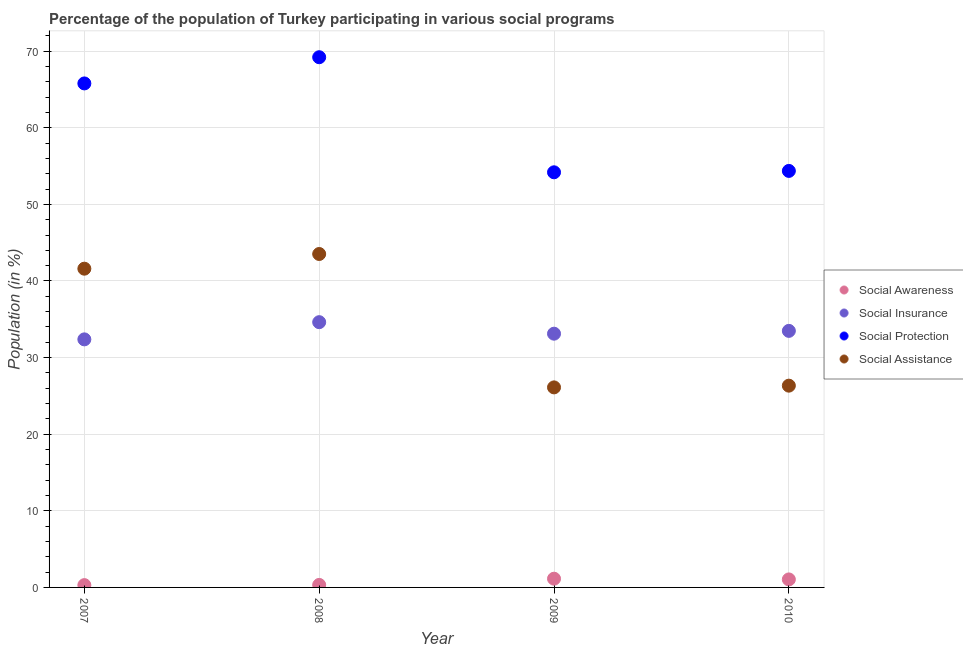How many different coloured dotlines are there?
Provide a short and direct response. 4. What is the participation of population in social protection programs in 2010?
Provide a succinct answer. 54.37. Across all years, what is the maximum participation of population in social awareness programs?
Your answer should be compact. 1.14. Across all years, what is the minimum participation of population in social protection programs?
Make the answer very short. 54.19. In which year was the participation of population in social insurance programs minimum?
Keep it short and to the point. 2007. What is the total participation of population in social awareness programs in the graph?
Keep it short and to the point. 2.81. What is the difference between the participation of population in social protection programs in 2007 and that in 2010?
Provide a succinct answer. 11.42. What is the difference between the participation of population in social insurance programs in 2010 and the participation of population in social awareness programs in 2009?
Ensure brevity in your answer.  32.35. What is the average participation of population in social assistance programs per year?
Provide a succinct answer. 34.39. In the year 2008, what is the difference between the participation of population in social protection programs and participation of population in social assistance programs?
Offer a very short reply. 25.68. In how many years, is the participation of population in social awareness programs greater than 60 %?
Your response must be concise. 0. What is the ratio of the participation of population in social assistance programs in 2007 to that in 2008?
Offer a very short reply. 0.96. Is the participation of population in social insurance programs in 2007 less than that in 2009?
Give a very brief answer. Yes. Is the difference between the participation of population in social insurance programs in 2007 and 2010 greater than the difference between the participation of population in social protection programs in 2007 and 2010?
Keep it short and to the point. No. What is the difference between the highest and the second highest participation of population in social insurance programs?
Make the answer very short. 1.14. What is the difference between the highest and the lowest participation of population in social awareness programs?
Give a very brief answer. 0.84. In how many years, is the participation of population in social insurance programs greater than the average participation of population in social insurance programs taken over all years?
Your response must be concise. 2. Is the sum of the participation of population in social insurance programs in 2007 and 2008 greater than the maximum participation of population in social awareness programs across all years?
Provide a short and direct response. Yes. Is it the case that in every year, the sum of the participation of population in social protection programs and participation of population in social assistance programs is greater than the sum of participation of population in social insurance programs and participation of population in social awareness programs?
Provide a short and direct response. No. Is it the case that in every year, the sum of the participation of population in social awareness programs and participation of population in social insurance programs is greater than the participation of population in social protection programs?
Offer a terse response. No. Does the participation of population in social awareness programs monotonically increase over the years?
Offer a terse response. No. Is the participation of population in social assistance programs strictly greater than the participation of population in social awareness programs over the years?
Provide a succinct answer. Yes. How many dotlines are there?
Make the answer very short. 4. How many years are there in the graph?
Your answer should be compact. 4. Are the values on the major ticks of Y-axis written in scientific E-notation?
Ensure brevity in your answer.  No. How many legend labels are there?
Provide a short and direct response. 4. What is the title of the graph?
Your answer should be compact. Percentage of the population of Turkey participating in various social programs . Does "Forest" appear as one of the legend labels in the graph?
Your answer should be very brief. No. What is the Population (in %) in Social Awareness in 2007?
Your response must be concise. 0.3. What is the Population (in %) of Social Insurance in 2007?
Your response must be concise. 32.38. What is the Population (in %) in Social Protection in 2007?
Provide a succinct answer. 65.79. What is the Population (in %) in Social Assistance in 2007?
Make the answer very short. 41.61. What is the Population (in %) of Social Awareness in 2008?
Keep it short and to the point. 0.33. What is the Population (in %) in Social Insurance in 2008?
Your answer should be very brief. 34.62. What is the Population (in %) of Social Protection in 2008?
Your answer should be very brief. 69.21. What is the Population (in %) of Social Assistance in 2008?
Provide a short and direct response. 43.52. What is the Population (in %) of Social Awareness in 2009?
Your answer should be compact. 1.14. What is the Population (in %) in Social Insurance in 2009?
Provide a short and direct response. 33.12. What is the Population (in %) of Social Protection in 2009?
Provide a short and direct response. 54.19. What is the Population (in %) of Social Assistance in 2009?
Offer a very short reply. 26.11. What is the Population (in %) in Social Awareness in 2010?
Give a very brief answer. 1.04. What is the Population (in %) in Social Insurance in 2010?
Provide a short and direct response. 33.49. What is the Population (in %) in Social Protection in 2010?
Your answer should be very brief. 54.37. What is the Population (in %) in Social Assistance in 2010?
Make the answer very short. 26.34. Across all years, what is the maximum Population (in %) of Social Awareness?
Provide a succinct answer. 1.14. Across all years, what is the maximum Population (in %) in Social Insurance?
Ensure brevity in your answer.  34.62. Across all years, what is the maximum Population (in %) in Social Protection?
Keep it short and to the point. 69.21. Across all years, what is the maximum Population (in %) of Social Assistance?
Your answer should be very brief. 43.52. Across all years, what is the minimum Population (in %) in Social Awareness?
Your answer should be compact. 0.3. Across all years, what is the minimum Population (in %) in Social Insurance?
Your response must be concise. 32.38. Across all years, what is the minimum Population (in %) in Social Protection?
Keep it short and to the point. 54.19. Across all years, what is the minimum Population (in %) of Social Assistance?
Offer a very short reply. 26.11. What is the total Population (in %) of Social Awareness in the graph?
Give a very brief answer. 2.81. What is the total Population (in %) of Social Insurance in the graph?
Give a very brief answer. 133.61. What is the total Population (in %) of Social Protection in the graph?
Your answer should be very brief. 243.55. What is the total Population (in %) in Social Assistance in the graph?
Offer a very short reply. 137.58. What is the difference between the Population (in %) in Social Awareness in 2007 and that in 2008?
Provide a short and direct response. -0.03. What is the difference between the Population (in %) of Social Insurance in 2007 and that in 2008?
Keep it short and to the point. -2.24. What is the difference between the Population (in %) of Social Protection in 2007 and that in 2008?
Your answer should be compact. -3.42. What is the difference between the Population (in %) in Social Assistance in 2007 and that in 2008?
Make the answer very short. -1.92. What is the difference between the Population (in %) in Social Awareness in 2007 and that in 2009?
Give a very brief answer. -0.84. What is the difference between the Population (in %) in Social Insurance in 2007 and that in 2009?
Provide a succinct answer. -0.74. What is the difference between the Population (in %) of Social Protection in 2007 and that in 2009?
Make the answer very short. 11.6. What is the difference between the Population (in %) of Social Assistance in 2007 and that in 2009?
Your response must be concise. 15.49. What is the difference between the Population (in %) of Social Awareness in 2007 and that in 2010?
Your response must be concise. -0.74. What is the difference between the Population (in %) of Social Insurance in 2007 and that in 2010?
Make the answer very short. -1.11. What is the difference between the Population (in %) of Social Protection in 2007 and that in 2010?
Give a very brief answer. 11.42. What is the difference between the Population (in %) in Social Assistance in 2007 and that in 2010?
Provide a short and direct response. 15.27. What is the difference between the Population (in %) in Social Awareness in 2008 and that in 2009?
Provide a short and direct response. -0.81. What is the difference between the Population (in %) of Social Insurance in 2008 and that in 2009?
Keep it short and to the point. 1.5. What is the difference between the Population (in %) in Social Protection in 2008 and that in 2009?
Your answer should be very brief. 15.02. What is the difference between the Population (in %) of Social Assistance in 2008 and that in 2009?
Make the answer very short. 17.41. What is the difference between the Population (in %) in Social Awareness in 2008 and that in 2010?
Provide a short and direct response. -0.72. What is the difference between the Population (in %) in Social Insurance in 2008 and that in 2010?
Give a very brief answer. 1.14. What is the difference between the Population (in %) in Social Protection in 2008 and that in 2010?
Offer a terse response. 14.84. What is the difference between the Population (in %) of Social Assistance in 2008 and that in 2010?
Ensure brevity in your answer.  17.19. What is the difference between the Population (in %) in Social Awareness in 2009 and that in 2010?
Your answer should be compact. 0.09. What is the difference between the Population (in %) in Social Insurance in 2009 and that in 2010?
Give a very brief answer. -0.37. What is the difference between the Population (in %) of Social Protection in 2009 and that in 2010?
Ensure brevity in your answer.  -0.18. What is the difference between the Population (in %) of Social Assistance in 2009 and that in 2010?
Keep it short and to the point. -0.23. What is the difference between the Population (in %) in Social Awareness in 2007 and the Population (in %) in Social Insurance in 2008?
Keep it short and to the point. -34.32. What is the difference between the Population (in %) in Social Awareness in 2007 and the Population (in %) in Social Protection in 2008?
Give a very brief answer. -68.91. What is the difference between the Population (in %) in Social Awareness in 2007 and the Population (in %) in Social Assistance in 2008?
Your answer should be very brief. -43.22. What is the difference between the Population (in %) of Social Insurance in 2007 and the Population (in %) of Social Protection in 2008?
Your answer should be very brief. -36.83. What is the difference between the Population (in %) of Social Insurance in 2007 and the Population (in %) of Social Assistance in 2008?
Your response must be concise. -11.14. What is the difference between the Population (in %) of Social Protection in 2007 and the Population (in %) of Social Assistance in 2008?
Make the answer very short. 22.26. What is the difference between the Population (in %) in Social Awareness in 2007 and the Population (in %) in Social Insurance in 2009?
Ensure brevity in your answer.  -32.82. What is the difference between the Population (in %) of Social Awareness in 2007 and the Population (in %) of Social Protection in 2009?
Offer a terse response. -53.89. What is the difference between the Population (in %) of Social Awareness in 2007 and the Population (in %) of Social Assistance in 2009?
Keep it short and to the point. -25.81. What is the difference between the Population (in %) in Social Insurance in 2007 and the Population (in %) in Social Protection in 2009?
Keep it short and to the point. -21.81. What is the difference between the Population (in %) in Social Insurance in 2007 and the Population (in %) in Social Assistance in 2009?
Keep it short and to the point. 6.27. What is the difference between the Population (in %) of Social Protection in 2007 and the Population (in %) of Social Assistance in 2009?
Ensure brevity in your answer.  39.68. What is the difference between the Population (in %) in Social Awareness in 2007 and the Population (in %) in Social Insurance in 2010?
Ensure brevity in your answer.  -33.19. What is the difference between the Population (in %) in Social Awareness in 2007 and the Population (in %) in Social Protection in 2010?
Make the answer very short. -54.07. What is the difference between the Population (in %) of Social Awareness in 2007 and the Population (in %) of Social Assistance in 2010?
Keep it short and to the point. -26.04. What is the difference between the Population (in %) in Social Insurance in 2007 and the Population (in %) in Social Protection in 2010?
Give a very brief answer. -21.99. What is the difference between the Population (in %) in Social Insurance in 2007 and the Population (in %) in Social Assistance in 2010?
Your response must be concise. 6.04. What is the difference between the Population (in %) of Social Protection in 2007 and the Population (in %) of Social Assistance in 2010?
Your response must be concise. 39.45. What is the difference between the Population (in %) of Social Awareness in 2008 and the Population (in %) of Social Insurance in 2009?
Ensure brevity in your answer.  -32.79. What is the difference between the Population (in %) of Social Awareness in 2008 and the Population (in %) of Social Protection in 2009?
Make the answer very short. -53.86. What is the difference between the Population (in %) in Social Awareness in 2008 and the Population (in %) in Social Assistance in 2009?
Offer a very short reply. -25.78. What is the difference between the Population (in %) of Social Insurance in 2008 and the Population (in %) of Social Protection in 2009?
Offer a very short reply. -19.56. What is the difference between the Population (in %) of Social Insurance in 2008 and the Population (in %) of Social Assistance in 2009?
Provide a succinct answer. 8.51. What is the difference between the Population (in %) of Social Protection in 2008 and the Population (in %) of Social Assistance in 2009?
Provide a short and direct response. 43.1. What is the difference between the Population (in %) in Social Awareness in 2008 and the Population (in %) in Social Insurance in 2010?
Your response must be concise. -33.16. What is the difference between the Population (in %) in Social Awareness in 2008 and the Population (in %) in Social Protection in 2010?
Make the answer very short. -54.04. What is the difference between the Population (in %) of Social Awareness in 2008 and the Population (in %) of Social Assistance in 2010?
Your answer should be very brief. -26.01. What is the difference between the Population (in %) in Social Insurance in 2008 and the Population (in %) in Social Protection in 2010?
Your answer should be very brief. -19.74. What is the difference between the Population (in %) in Social Insurance in 2008 and the Population (in %) in Social Assistance in 2010?
Make the answer very short. 8.29. What is the difference between the Population (in %) in Social Protection in 2008 and the Population (in %) in Social Assistance in 2010?
Offer a very short reply. 42.87. What is the difference between the Population (in %) in Social Awareness in 2009 and the Population (in %) in Social Insurance in 2010?
Offer a very short reply. -32.35. What is the difference between the Population (in %) of Social Awareness in 2009 and the Population (in %) of Social Protection in 2010?
Offer a terse response. -53.23. What is the difference between the Population (in %) in Social Awareness in 2009 and the Population (in %) in Social Assistance in 2010?
Your response must be concise. -25.2. What is the difference between the Population (in %) of Social Insurance in 2009 and the Population (in %) of Social Protection in 2010?
Provide a succinct answer. -21.25. What is the difference between the Population (in %) of Social Insurance in 2009 and the Population (in %) of Social Assistance in 2010?
Keep it short and to the point. 6.78. What is the difference between the Population (in %) of Social Protection in 2009 and the Population (in %) of Social Assistance in 2010?
Give a very brief answer. 27.85. What is the average Population (in %) in Social Awareness per year?
Offer a very short reply. 0.7. What is the average Population (in %) of Social Insurance per year?
Your answer should be very brief. 33.4. What is the average Population (in %) of Social Protection per year?
Ensure brevity in your answer.  60.89. What is the average Population (in %) of Social Assistance per year?
Ensure brevity in your answer.  34.39. In the year 2007, what is the difference between the Population (in %) in Social Awareness and Population (in %) in Social Insurance?
Your answer should be compact. -32.08. In the year 2007, what is the difference between the Population (in %) of Social Awareness and Population (in %) of Social Protection?
Provide a succinct answer. -65.49. In the year 2007, what is the difference between the Population (in %) of Social Awareness and Population (in %) of Social Assistance?
Your answer should be very brief. -41.3. In the year 2007, what is the difference between the Population (in %) in Social Insurance and Population (in %) in Social Protection?
Ensure brevity in your answer.  -33.41. In the year 2007, what is the difference between the Population (in %) of Social Insurance and Population (in %) of Social Assistance?
Your answer should be compact. -9.23. In the year 2007, what is the difference between the Population (in %) in Social Protection and Population (in %) in Social Assistance?
Your answer should be compact. 24.18. In the year 2008, what is the difference between the Population (in %) in Social Awareness and Population (in %) in Social Insurance?
Your answer should be very brief. -34.3. In the year 2008, what is the difference between the Population (in %) of Social Awareness and Population (in %) of Social Protection?
Ensure brevity in your answer.  -68.88. In the year 2008, what is the difference between the Population (in %) of Social Awareness and Population (in %) of Social Assistance?
Your answer should be compact. -43.2. In the year 2008, what is the difference between the Population (in %) in Social Insurance and Population (in %) in Social Protection?
Make the answer very short. -34.58. In the year 2008, what is the difference between the Population (in %) in Social Insurance and Population (in %) in Social Assistance?
Keep it short and to the point. -8.9. In the year 2008, what is the difference between the Population (in %) in Social Protection and Population (in %) in Social Assistance?
Provide a short and direct response. 25.68. In the year 2009, what is the difference between the Population (in %) of Social Awareness and Population (in %) of Social Insurance?
Your response must be concise. -31.98. In the year 2009, what is the difference between the Population (in %) in Social Awareness and Population (in %) in Social Protection?
Offer a terse response. -53.05. In the year 2009, what is the difference between the Population (in %) of Social Awareness and Population (in %) of Social Assistance?
Your response must be concise. -24.97. In the year 2009, what is the difference between the Population (in %) in Social Insurance and Population (in %) in Social Protection?
Offer a very short reply. -21.07. In the year 2009, what is the difference between the Population (in %) in Social Insurance and Population (in %) in Social Assistance?
Provide a short and direct response. 7.01. In the year 2009, what is the difference between the Population (in %) of Social Protection and Population (in %) of Social Assistance?
Your response must be concise. 28.08. In the year 2010, what is the difference between the Population (in %) of Social Awareness and Population (in %) of Social Insurance?
Give a very brief answer. -32.44. In the year 2010, what is the difference between the Population (in %) of Social Awareness and Population (in %) of Social Protection?
Keep it short and to the point. -53.32. In the year 2010, what is the difference between the Population (in %) in Social Awareness and Population (in %) in Social Assistance?
Keep it short and to the point. -25.29. In the year 2010, what is the difference between the Population (in %) in Social Insurance and Population (in %) in Social Protection?
Your response must be concise. -20.88. In the year 2010, what is the difference between the Population (in %) in Social Insurance and Population (in %) in Social Assistance?
Provide a succinct answer. 7.15. In the year 2010, what is the difference between the Population (in %) of Social Protection and Population (in %) of Social Assistance?
Keep it short and to the point. 28.03. What is the ratio of the Population (in %) of Social Awareness in 2007 to that in 2008?
Make the answer very short. 0.92. What is the ratio of the Population (in %) of Social Insurance in 2007 to that in 2008?
Offer a terse response. 0.94. What is the ratio of the Population (in %) of Social Protection in 2007 to that in 2008?
Provide a short and direct response. 0.95. What is the ratio of the Population (in %) of Social Assistance in 2007 to that in 2008?
Ensure brevity in your answer.  0.96. What is the ratio of the Population (in %) of Social Awareness in 2007 to that in 2009?
Offer a terse response. 0.26. What is the ratio of the Population (in %) of Social Insurance in 2007 to that in 2009?
Your answer should be very brief. 0.98. What is the ratio of the Population (in %) of Social Protection in 2007 to that in 2009?
Your answer should be very brief. 1.21. What is the ratio of the Population (in %) of Social Assistance in 2007 to that in 2009?
Make the answer very short. 1.59. What is the ratio of the Population (in %) in Social Awareness in 2007 to that in 2010?
Your answer should be compact. 0.29. What is the ratio of the Population (in %) of Social Insurance in 2007 to that in 2010?
Your response must be concise. 0.97. What is the ratio of the Population (in %) in Social Protection in 2007 to that in 2010?
Offer a very short reply. 1.21. What is the ratio of the Population (in %) in Social Assistance in 2007 to that in 2010?
Offer a very short reply. 1.58. What is the ratio of the Population (in %) of Social Awareness in 2008 to that in 2009?
Offer a terse response. 0.29. What is the ratio of the Population (in %) in Social Insurance in 2008 to that in 2009?
Your answer should be very brief. 1.05. What is the ratio of the Population (in %) in Social Protection in 2008 to that in 2009?
Provide a short and direct response. 1.28. What is the ratio of the Population (in %) of Social Assistance in 2008 to that in 2009?
Your answer should be very brief. 1.67. What is the ratio of the Population (in %) of Social Awareness in 2008 to that in 2010?
Keep it short and to the point. 0.31. What is the ratio of the Population (in %) in Social Insurance in 2008 to that in 2010?
Make the answer very short. 1.03. What is the ratio of the Population (in %) of Social Protection in 2008 to that in 2010?
Provide a short and direct response. 1.27. What is the ratio of the Population (in %) in Social Assistance in 2008 to that in 2010?
Your response must be concise. 1.65. What is the ratio of the Population (in %) of Social Awareness in 2009 to that in 2010?
Offer a terse response. 1.09. What is the ratio of the Population (in %) in Social Insurance in 2009 to that in 2010?
Offer a very short reply. 0.99. What is the difference between the highest and the second highest Population (in %) of Social Awareness?
Your response must be concise. 0.09. What is the difference between the highest and the second highest Population (in %) in Social Insurance?
Make the answer very short. 1.14. What is the difference between the highest and the second highest Population (in %) in Social Protection?
Provide a short and direct response. 3.42. What is the difference between the highest and the second highest Population (in %) of Social Assistance?
Your response must be concise. 1.92. What is the difference between the highest and the lowest Population (in %) in Social Awareness?
Offer a very short reply. 0.84. What is the difference between the highest and the lowest Population (in %) in Social Insurance?
Offer a very short reply. 2.24. What is the difference between the highest and the lowest Population (in %) in Social Protection?
Give a very brief answer. 15.02. What is the difference between the highest and the lowest Population (in %) of Social Assistance?
Provide a short and direct response. 17.41. 